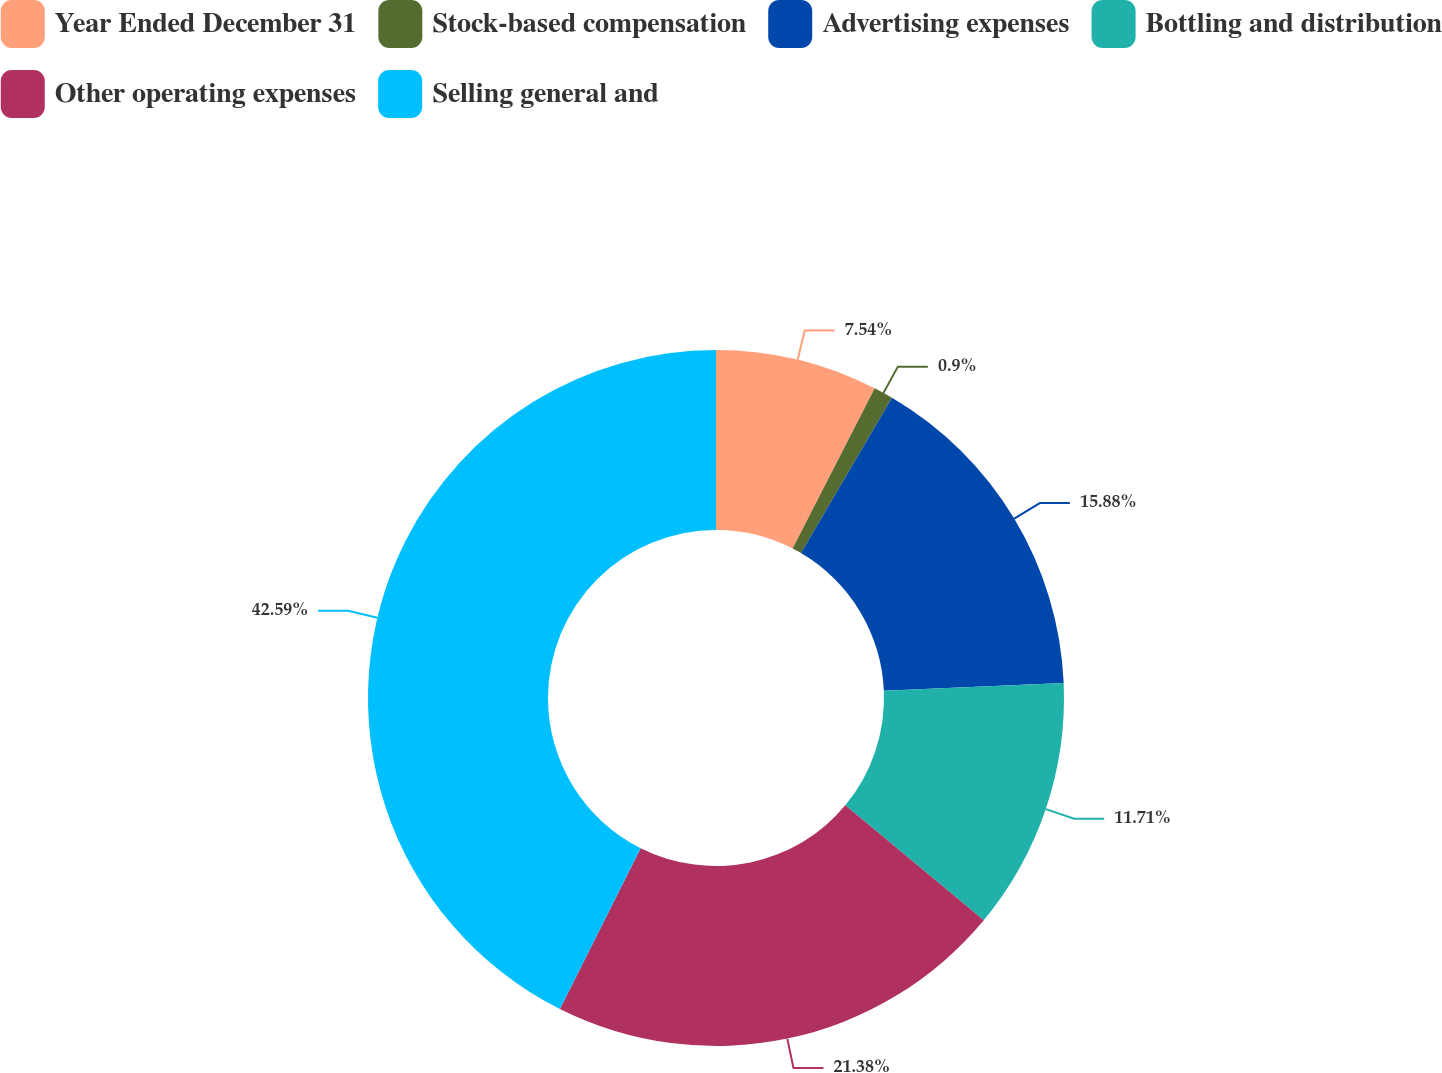Convert chart to OTSL. <chart><loc_0><loc_0><loc_500><loc_500><pie_chart><fcel>Year Ended December 31<fcel>Stock-based compensation<fcel>Advertising expenses<fcel>Bottling and distribution<fcel>Other operating expenses<fcel>Selling general and<nl><fcel>7.54%<fcel>0.9%<fcel>15.88%<fcel>11.71%<fcel>21.38%<fcel>42.6%<nl></chart> 